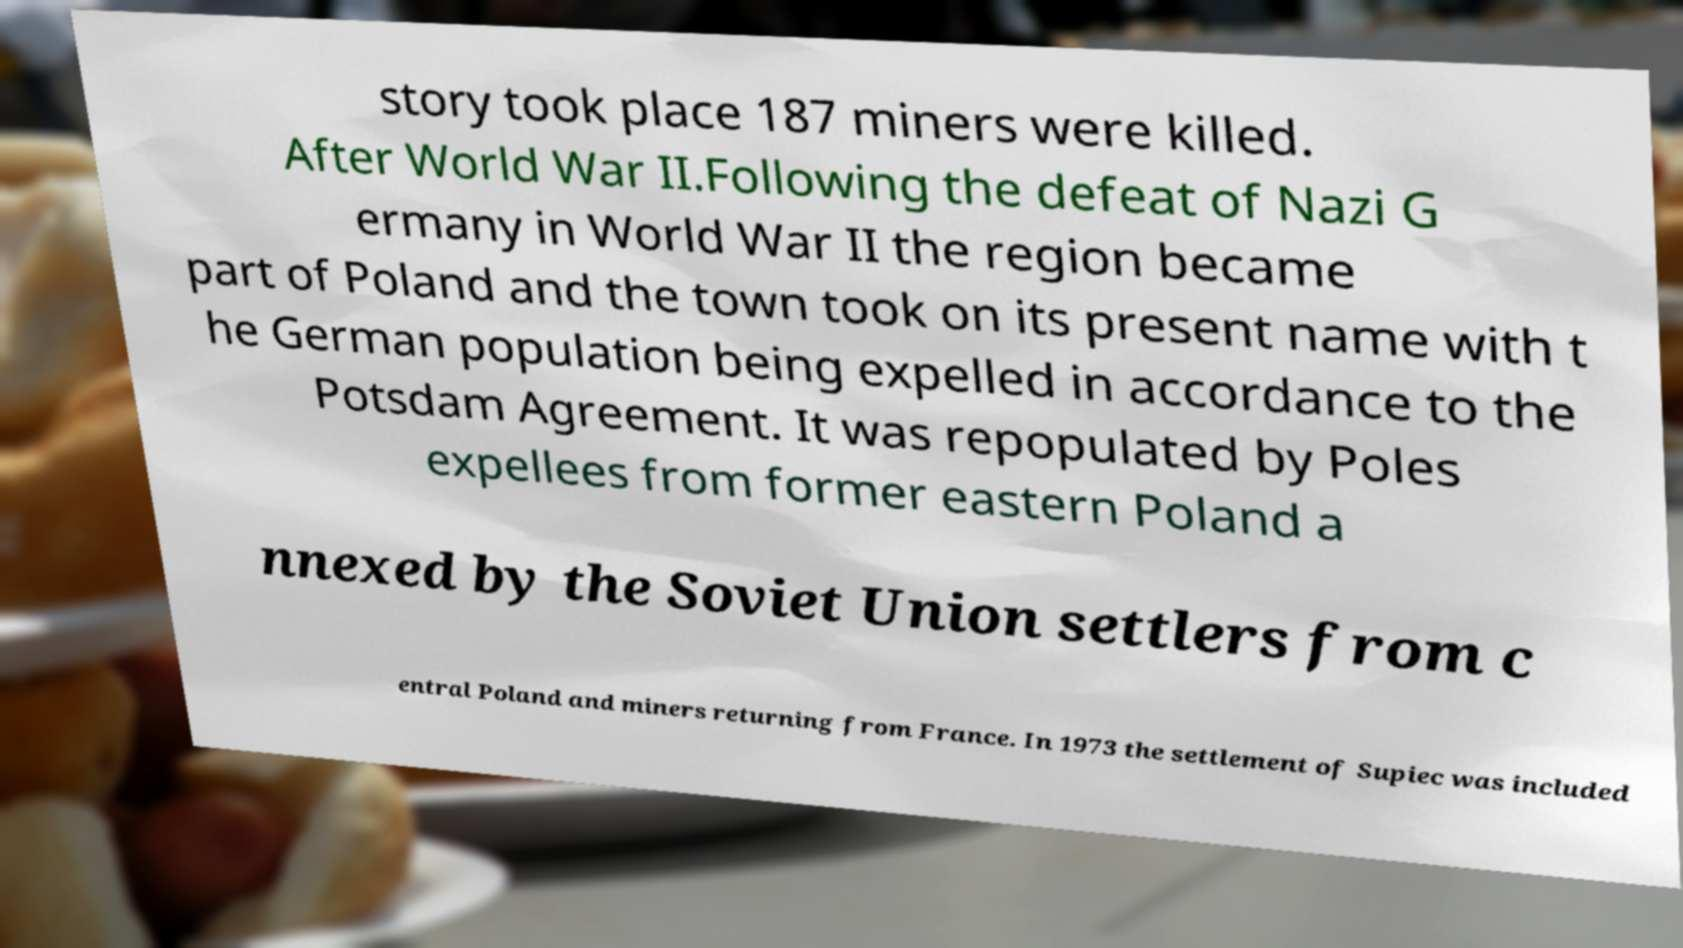Can you accurately transcribe the text from the provided image for me? story took place 187 miners were killed. After World War II.Following the defeat of Nazi G ermany in World War II the region became part of Poland and the town took on its present name with t he German population being expelled in accordance to the Potsdam Agreement. It was repopulated by Poles expellees from former eastern Poland a nnexed by the Soviet Union settlers from c entral Poland and miners returning from France. In 1973 the settlement of Supiec was included 